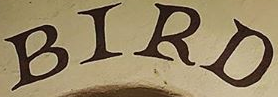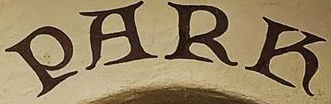Read the text content from these images in order, separated by a semicolon. BIRD; PARK 